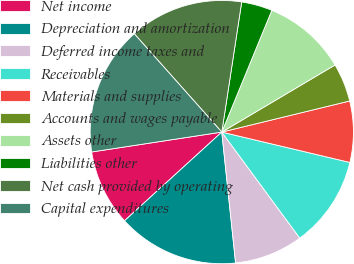<chart> <loc_0><loc_0><loc_500><loc_500><pie_chart><fcel>Net income<fcel>Depreciation and amortization<fcel>Deferred income taxes and<fcel>Receivables<fcel>Materials and supplies<fcel>Accounts and wages payable<fcel>Assets other<fcel>Liabilities other<fcel>Net cash provided by operating<fcel>Capital expenditures<nl><fcel>9.35%<fcel>14.91%<fcel>8.42%<fcel>11.2%<fcel>7.5%<fcel>4.72%<fcel>10.28%<fcel>3.79%<fcel>13.99%<fcel>15.84%<nl></chart> 